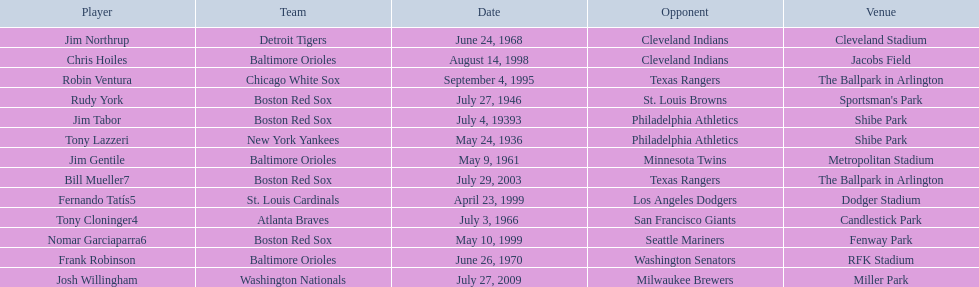What is the name of the player for the new york yankees in 1936? Tony Lazzeri. 